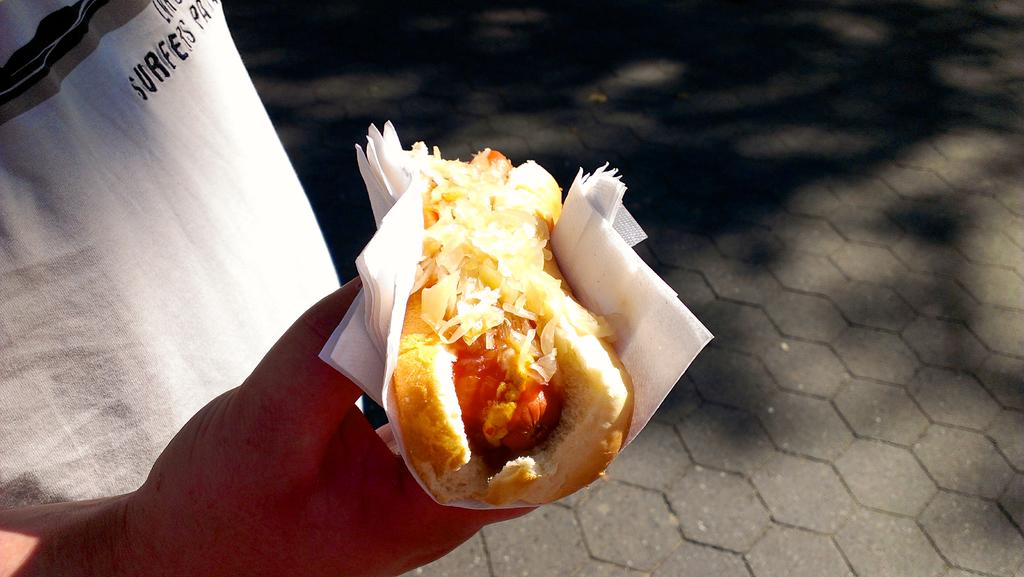What can be seen in the image? There is a person in the image. What is the person holding in their hand? The person is holding a food item in their hand. What is the person wearing? The person is wearing a white t-shirt. Can you describe the mountain range in the background of the image? There is no mountain range present in the image; it only features a person holding a food item and wearing a white t-shirt. 